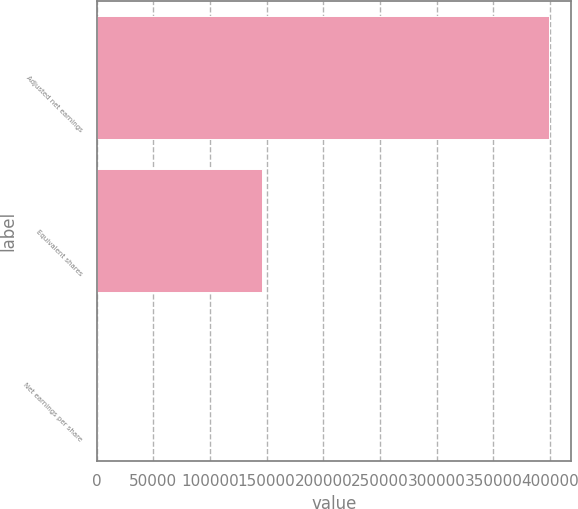Convert chart to OTSL. <chart><loc_0><loc_0><loc_500><loc_500><bar_chart><fcel>Adjusted net earnings<fcel>Equivalent shares<fcel>Net earnings per share<nl><fcel>398876<fcel>145670<fcel>2.74<nl></chart> 